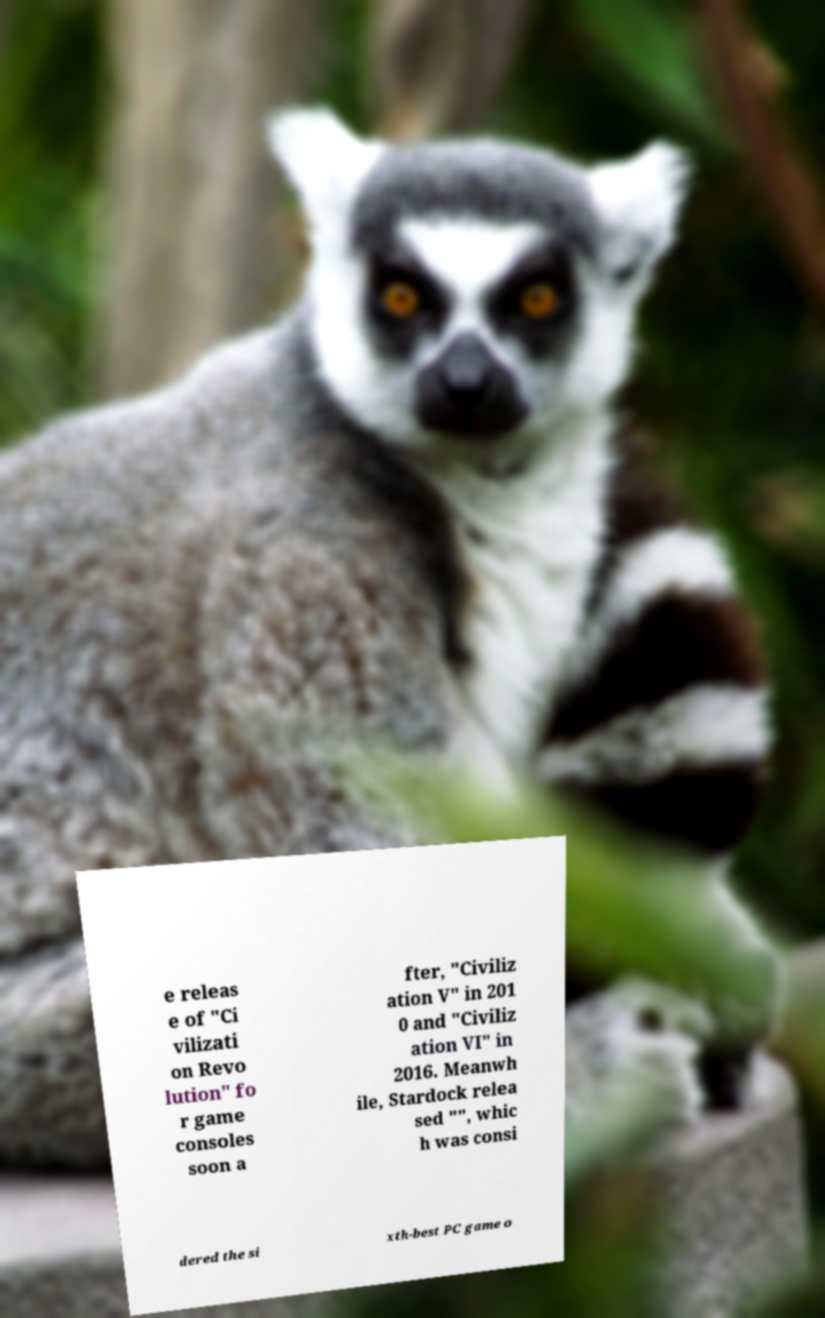Can you read and provide the text displayed in the image?This photo seems to have some interesting text. Can you extract and type it out for me? e releas e of "Ci vilizati on Revo lution" fo r game consoles soon a fter, "Civiliz ation V" in 201 0 and "Civiliz ation VI" in 2016. Meanwh ile, Stardock relea sed "", whic h was consi dered the si xth-best PC game o 